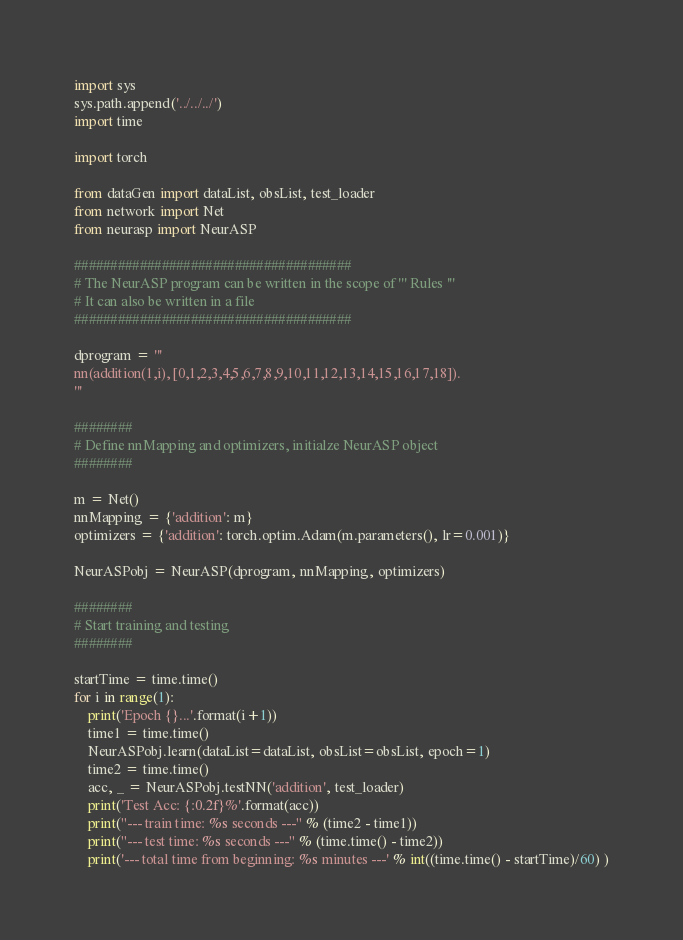Convert code to text. <code><loc_0><loc_0><loc_500><loc_500><_Python_>import sys
sys.path.append('../../../')
import time

import torch

from dataGen import dataList, obsList, test_loader
from network import Net
from neurasp import NeurASP

######################################
# The NeurASP program can be written in the scope of ''' Rules '''
# It can also be written in a file
######################################

dprogram = '''
nn(addition(1,i), [0,1,2,3,4,5,6,7,8,9,10,11,12,13,14,15,16,17,18]).
'''

########
# Define nnMapping and optimizers, initialze NeurASP object
########

m = Net()
nnMapping = {'addition': m}
optimizers = {'addition': torch.optim.Adam(m.parameters(), lr=0.001)}

NeurASPobj = NeurASP(dprogram, nnMapping, optimizers)

########
# Start training and testing
########

startTime = time.time()
for i in range(1):
    print('Epoch {}...'.format(i+1))
    time1 = time.time()
    NeurASPobj.learn(dataList=dataList, obsList=obsList, epoch=1)
    time2 = time.time()
    acc, _ = NeurASPobj.testNN('addition', test_loader)
    print('Test Acc: {:0.2f}%'.format(acc))
    print("--- train time: %s seconds ---" % (time2 - time1))
    print("--- test time: %s seconds ---" % (time.time() - time2))
    print('--- total time from beginning: %s minutes ---' % int((time.time() - startTime)/60) )</code> 